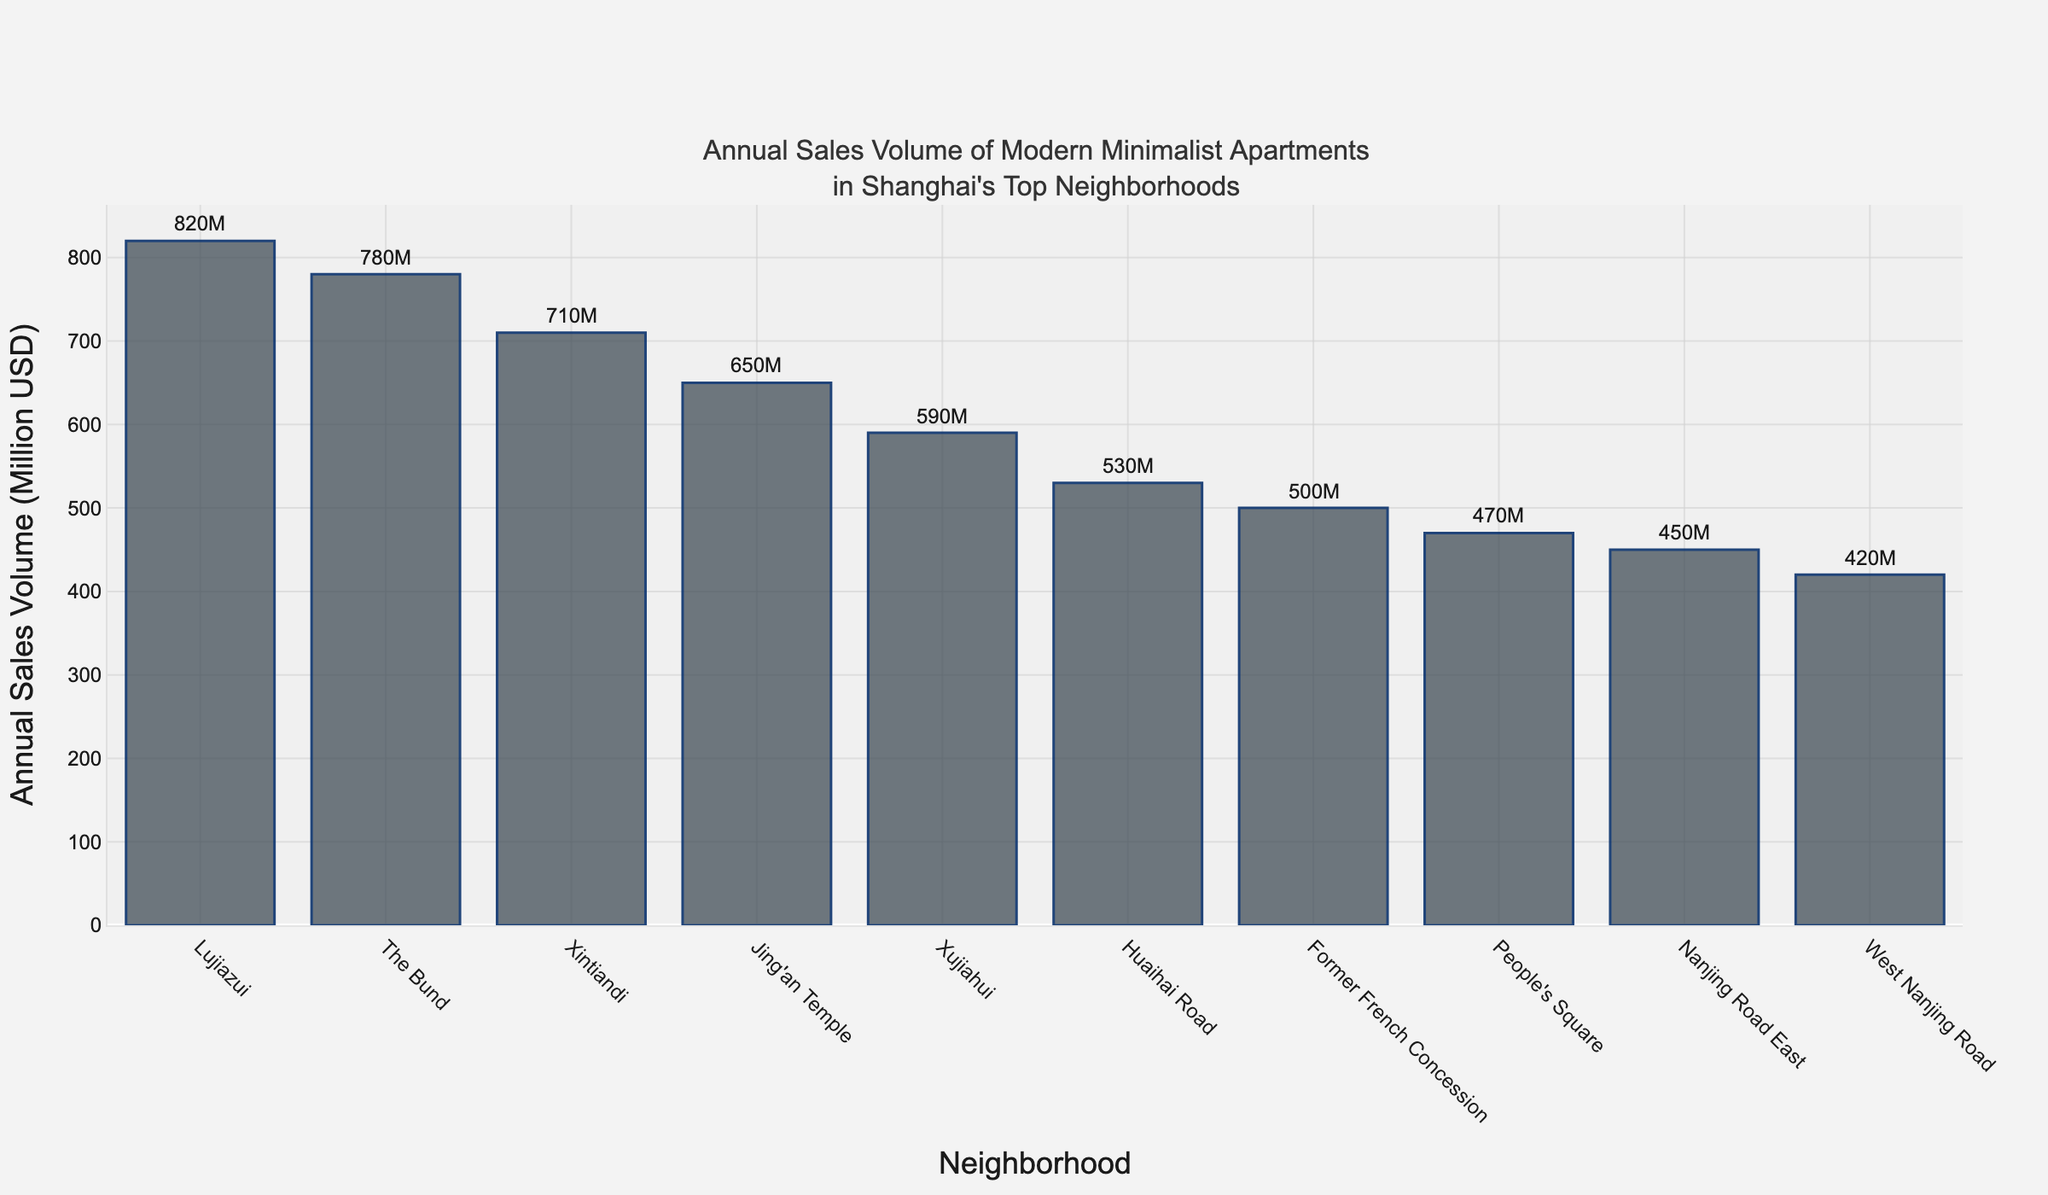which neighborhood has the highest annual sales volume? The bar chart shows that the tallest bar represents Lujiazui, indicating that it has the highest annual sales volume.
Answer: Lujiazui what's the difference in annual sales volume between lujiazui and the bund? The annual sales volume for Lujiazui is 820 million USD, and for The Bund, it is 780 million USD. The difference is 820 - 780 = 40 million USD.
Answer: 40 million USD what is the combined sales volume of jing'an temple and xujiahui? The annual sales volume for Jing'an Temple is 650 million USD, and for Xujiahui, it is 590 million USD. The combined sales volume is 650 + 590 = 1240 million USD.
Answer: 1240 million USD which neighborhoods have an annual sales volume less than 500 million usd? The bar chart shows that Former French Concession, People's Square, and Nanjing Road East have annual sales volumes less than 500 million USD.
Answer: Former French Concession, People's Square, Nanjing Road East what's the average annual sales volume of the top 5 most expensive neighborhoods? The top 5 most expensive neighborhoods are Lujiazui (820 million USD), The Bund (780 million USD), Xintiandi (710 million USD), Jing'an Temple (650 million USD), and Xujiahui (590 million USD). The average is (820 + 780 + 710 + 650 + 590)/5 = 710 million USD.
Answer: 710 million USD how many neighborhoods have a sales volume greater than 600 million usd? From the bar chart, it is clear that the neighborhoods with a sales volume greater than 600 million USD are Lujiazui, The Bund, Xintiandi, and Jing'an Temple, totaling four neighborhoods.
Answer: 4 is the annual sales volume of west nanjing road more than half of the volume of xujiahui? The annual sales volume of West Nanjing Road is 420 million USD, and the volume of Xujiahui is 590 million USD. Half of 590 is 295, and since 420 is greater than 295, this statement is true.
Answer: Yes what is the visual difference between the bar representing lujiazui and the bar representing huaihai road? The bar representing Lujiazui is significantly taller than the bar representing Huaihai Road, indicating a higher annual sales volume in Lujiazui.
Answer: Taller what is the sum of the annual sales volumes of the bottom 3 neighborhoods? The bottom 3 neighborhoods are People's Square (470 million USD), Nanjing Road East (450 million USD), and West Nanjing Road (420 million USD). The sum is 470 + 450 + 420 = 1340 million USD.
Answer: 1340 million USD 